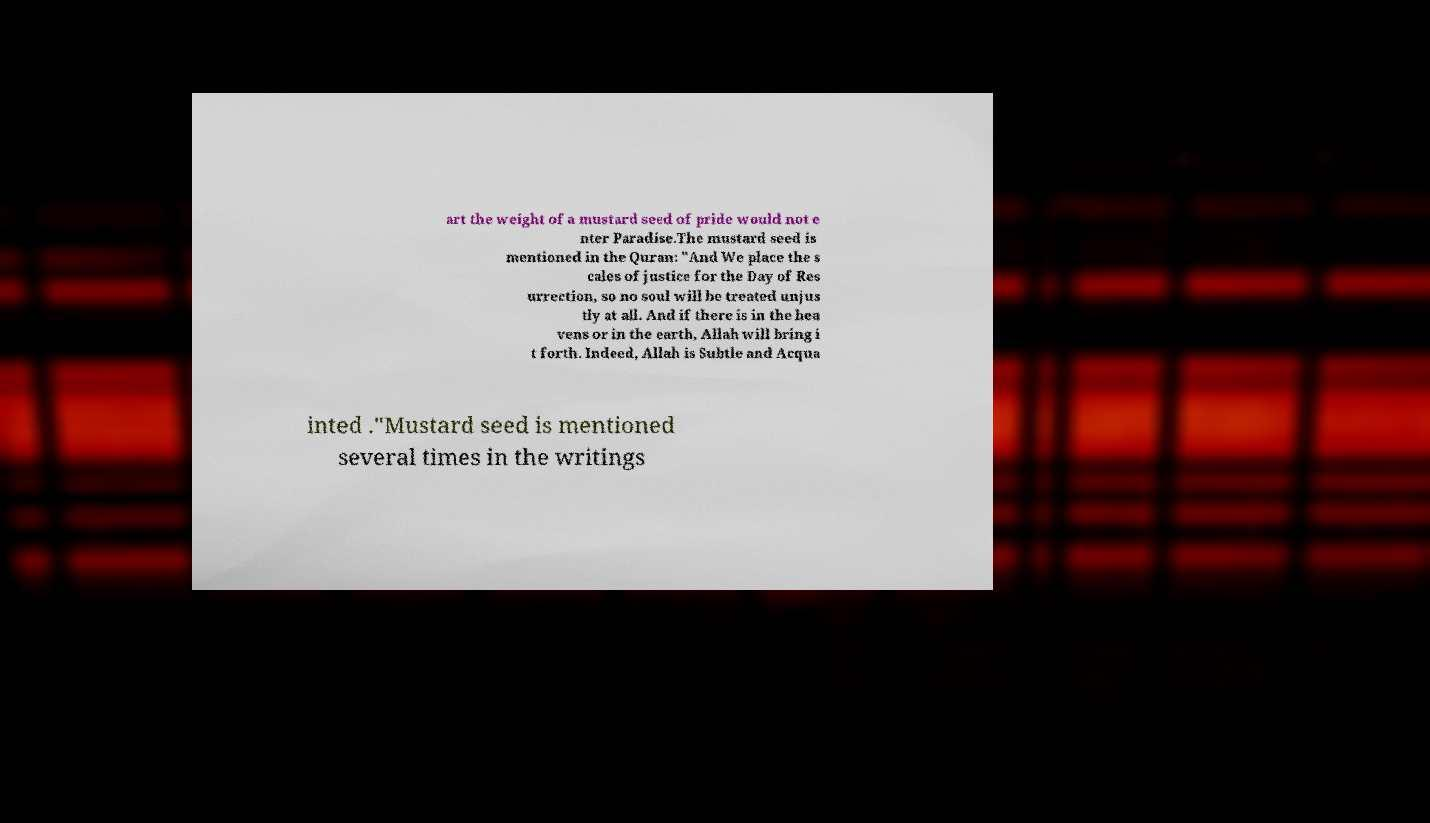Please read and relay the text visible in this image. What does it say? art the weight of a mustard seed of pride would not e nter Paradise.The mustard seed is mentioned in the Quran: "And We place the s cales of justice for the Day of Res urrection, so no soul will be treated unjus tly at all. And if there is in the hea vens or in the earth, Allah will bring i t forth. Indeed, Allah is Subtle and Acqua inted ."Mustard seed is mentioned several times in the writings 